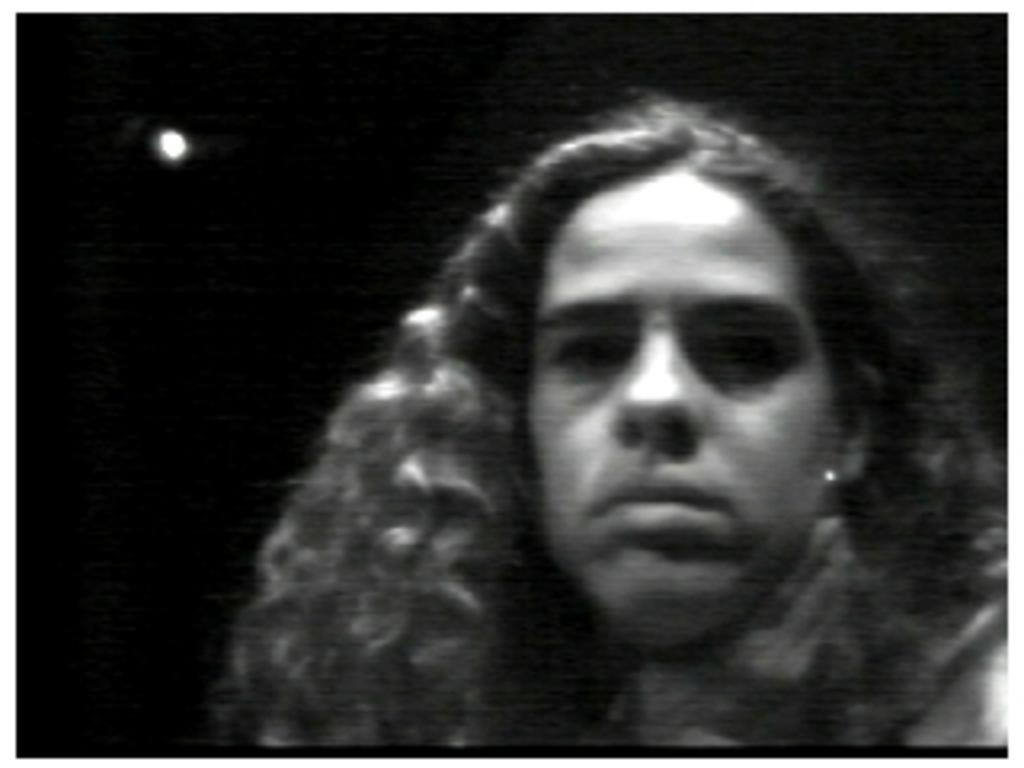What is the main subject of the image? There is a woman in the image. Can you describe the background of the image? The background of the image is dark. What type of engine can be seen in the woman's eye in the image? There is no engine or any mechanical parts visible in the woman's eye in the image. 